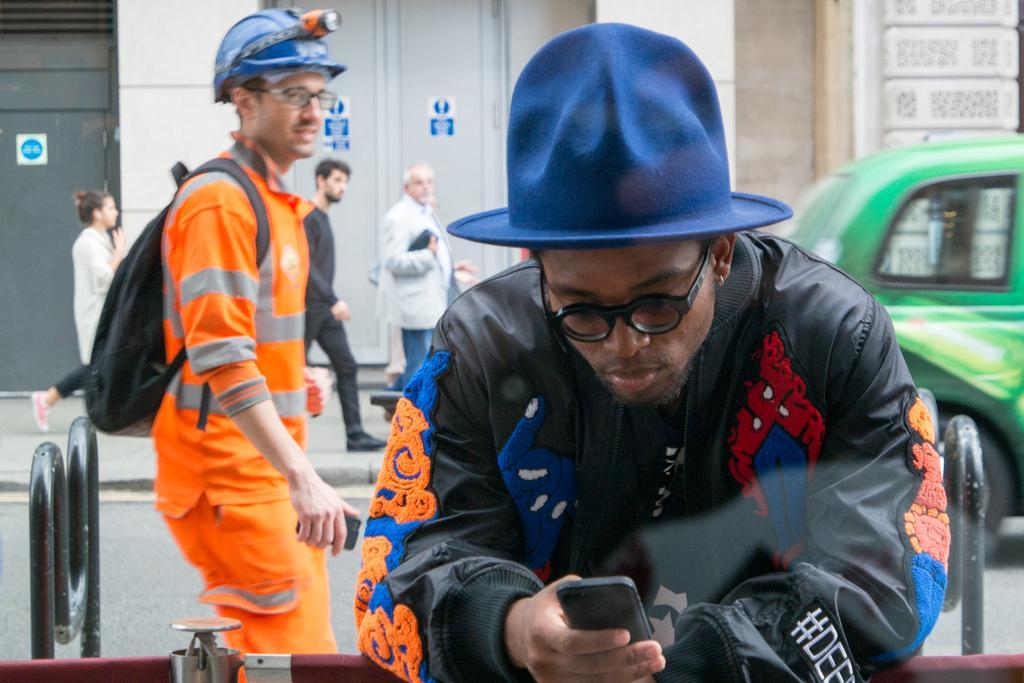In one or two sentences, can you explain what this image depicts? In the background we can see stickers on the doors. In this picture we can see people on the pathway. We can see a man wearing a cap and holding an object. On the left side of the picture we can see a person wearing a helmet, backpack and holding an object. On the right side of the picture we can see the partial part of a vehicle on the road. We can see few objects. 